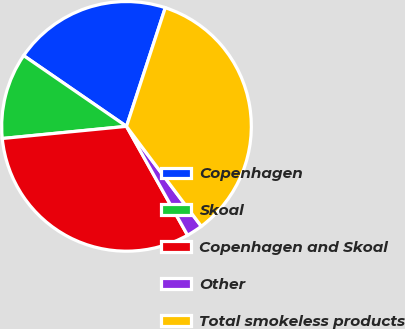<chart> <loc_0><loc_0><loc_500><loc_500><pie_chart><fcel>Copenhagen<fcel>Skoal<fcel>Copenhagen and Skoal<fcel>Other<fcel>Total smokeless products<nl><fcel>20.44%<fcel>11.14%<fcel>31.58%<fcel>2.09%<fcel>34.74%<nl></chart> 